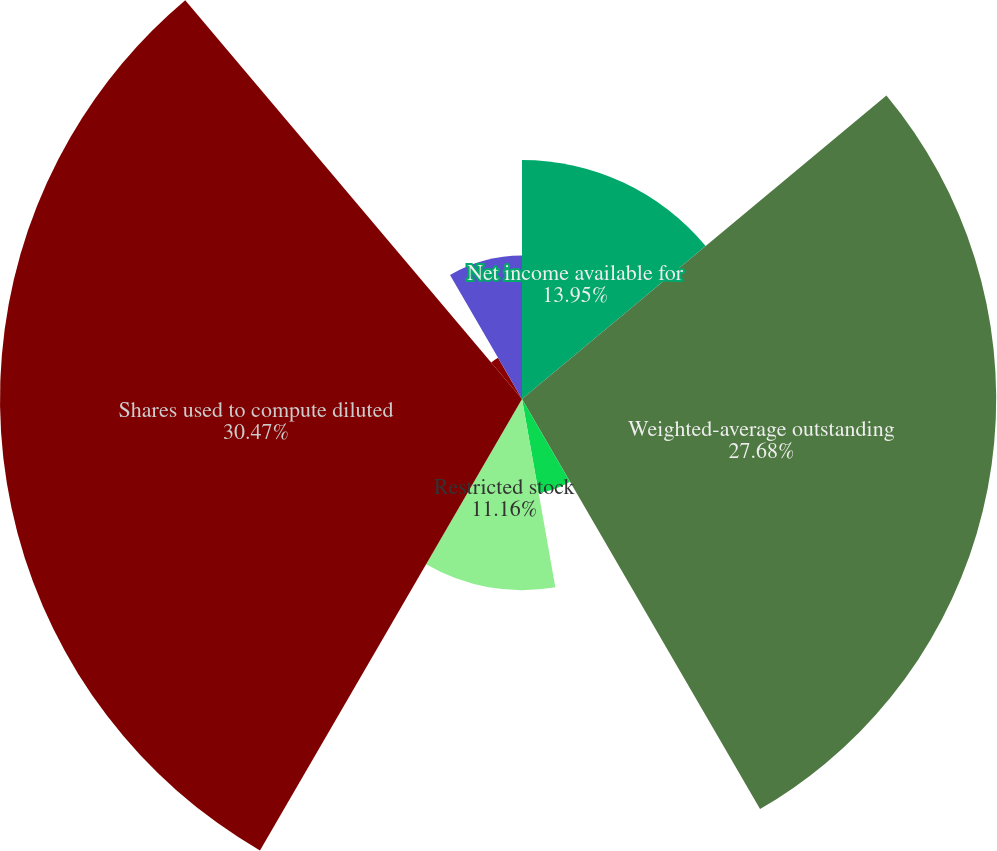Convert chart. <chart><loc_0><loc_0><loc_500><loc_500><pie_chart><fcel>Net income available for<fcel>Weighted-average outstanding<fcel>Employee stock options<fcel>Restricted stock<fcel>Shares used to compute diluted<fcel>Basic earnings per common<fcel>Diluted earnings per common<fcel>Number of antidilutive stock<nl><fcel>13.95%<fcel>27.68%<fcel>5.58%<fcel>11.16%<fcel>30.47%<fcel>2.79%<fcel>0.0%<fcel>8.37%<nl></chart> 